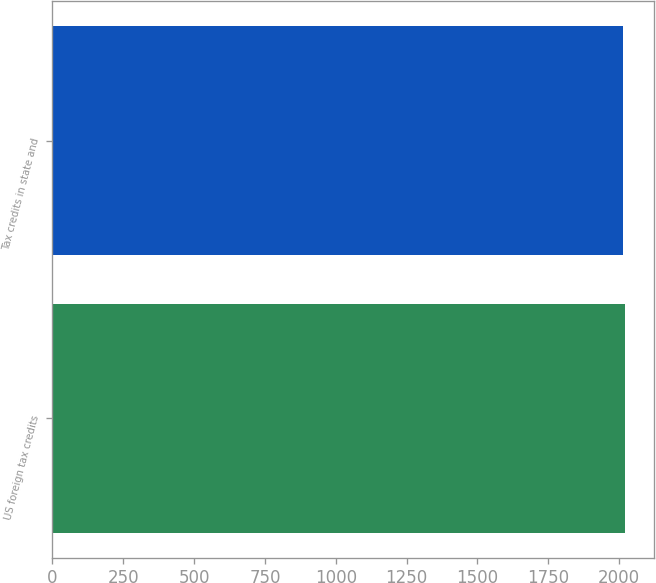<chart> <loc_0><loc_0><loc_500><loc_500><bar_chart><fcel>US foreign tax credits<fcel>Tax credits in state and<nl><fcel>2021<fcel>2014<nl></chart> 